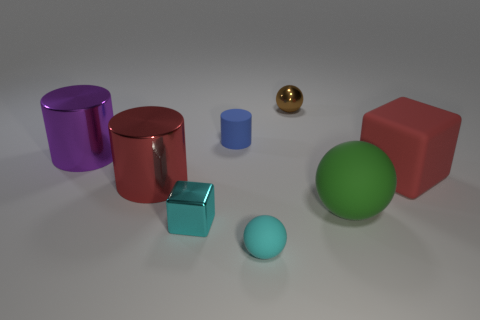Are there any reflective surfaces in the scene? Yes, there are objects with reflective surfaces in the scene. The small gold sphere and the small light blue cube both have shiny, reflective surfaces. 